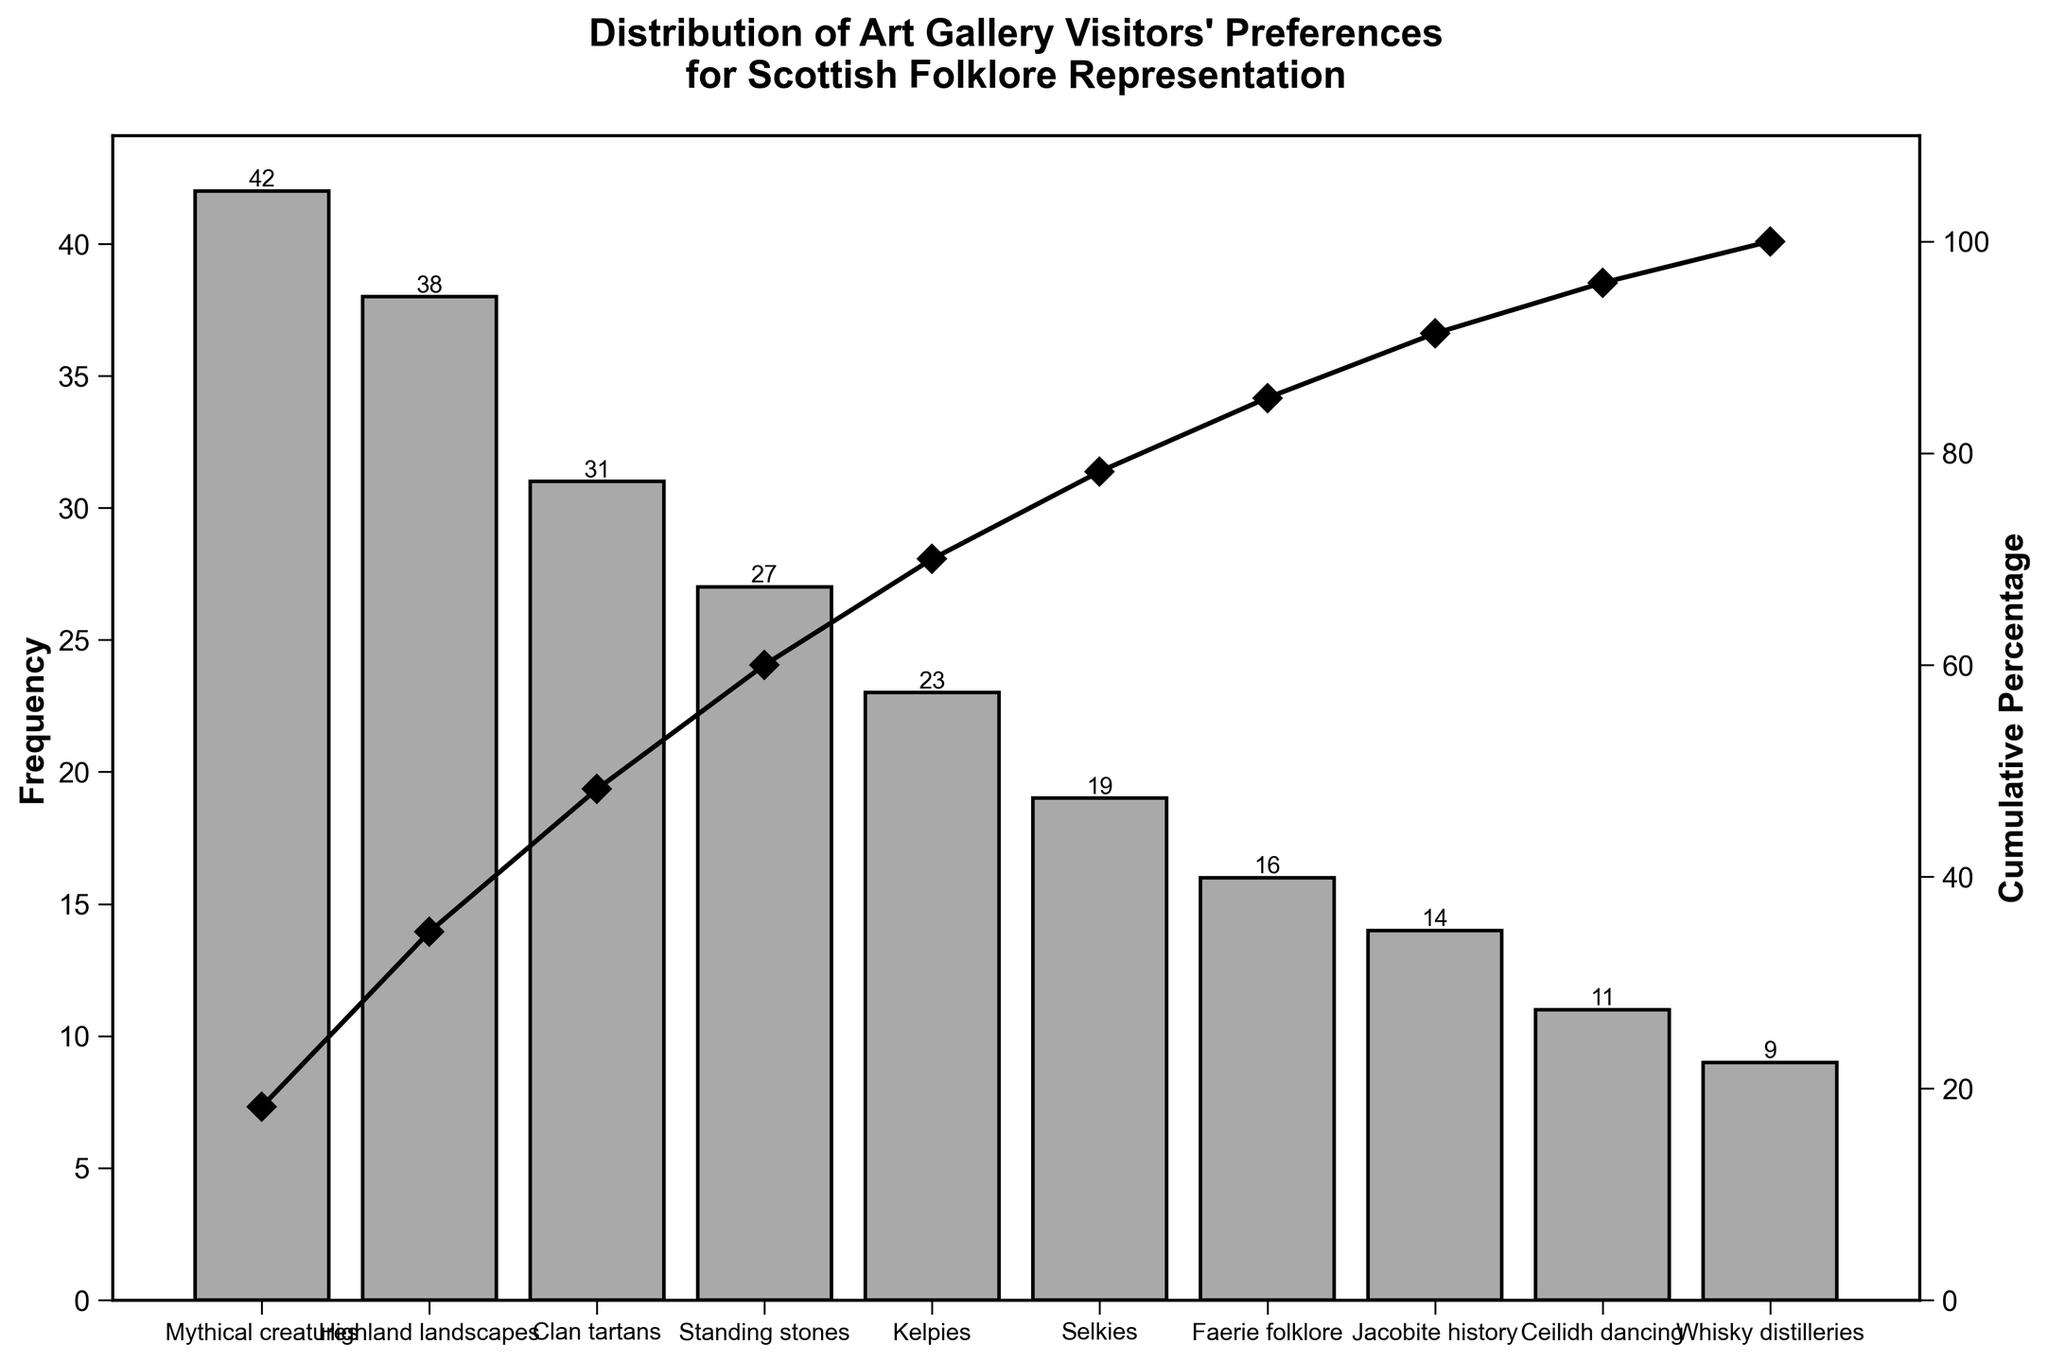Which aspect of Scottish folklore is most favored by art gallery visitors? The aspect with the highest frequency bar represents the most favored. The tallest bar is for "Mythical creatures" with a frequency of 42.
Answer: Mythical creatures What is the cumulative percentage up to the third most favored aspect? Locate the cumulative percentage at the third bar, which includes "Mythical creatures", "Highland landscapes", and "Clan tartans". Summing their frequencies (42 + 38 + 31) and dividing by the total (230) gives approximately 48.7%, visible on the chart.
Answer: 48.7% Which aspect of folklore is just below "Selkies" in popularity? Identify "Selkies" in the list and look for the aspect immediately below it. The next aspect is "Faerie folklore" with a frequency of 16.
Answer: Faerie folklore How much more popular are "Mythical creatures" compared to "Whisky distilleries"? Subtract the frequency of "Whisky distilleries" (9) from "Mythical creatures" (42). 42 - 9 = 33.
Answer: 33 What percentage of visitors prefer "Standing stones" or more popular aspects combined? Add the frequencies of "Standing stones" and all more popular aspects: (27 + 31 + 38 + 42) and divide by the total (230), then multiply by 100 for the percentage. (27+31+38+42)/230 * 100 ≈ 60.9%.
Answer: 60.9% Which aspects together account for around 50% of visitor preferences? Check the cumulative percentage and identify the aspects whose sum approximates 50%. This includes "Mythical creatures", "Highland landscapes", and "Clan tartans". Their cumulative percentage is around 48.7%, close to 50%.
Answer: Mythical creatures, Highland landscapes, Clan tartans What is the frequency difference between the aspect with the least and the aspect with the most preferences? Subtract the frequency of the least popular aspect "Whisky distilleries" (9) from the most popular aspect "Mythical creatures" (42). 42 - 9 = 33.
Answer: 33 What cumulative percentage does "Ceilidh dancing" represent? Find "Ceilidh dancing" in the list and check its cumulative percentage line point value. The cumulative percentage for "Ceilidh dancing" is visible as around 92.2%.
Answer: 92.2% How many aspects have a frequency higher than 20? Count all bars with frequencies above 20. These aspects are "Mythical creatures", "Highland landscapes", "Clan tartans", "Standing stones", and "Kelpies", totaling 5 aspects.
Answer: 5 What aspect has a similar frequency to "Kelpies"? Compare the bar heights to identify the closest frequency to "Kelpies" (23). "Selkies" has a frequency of 19, which is relatively close.
Answer: Selkies 